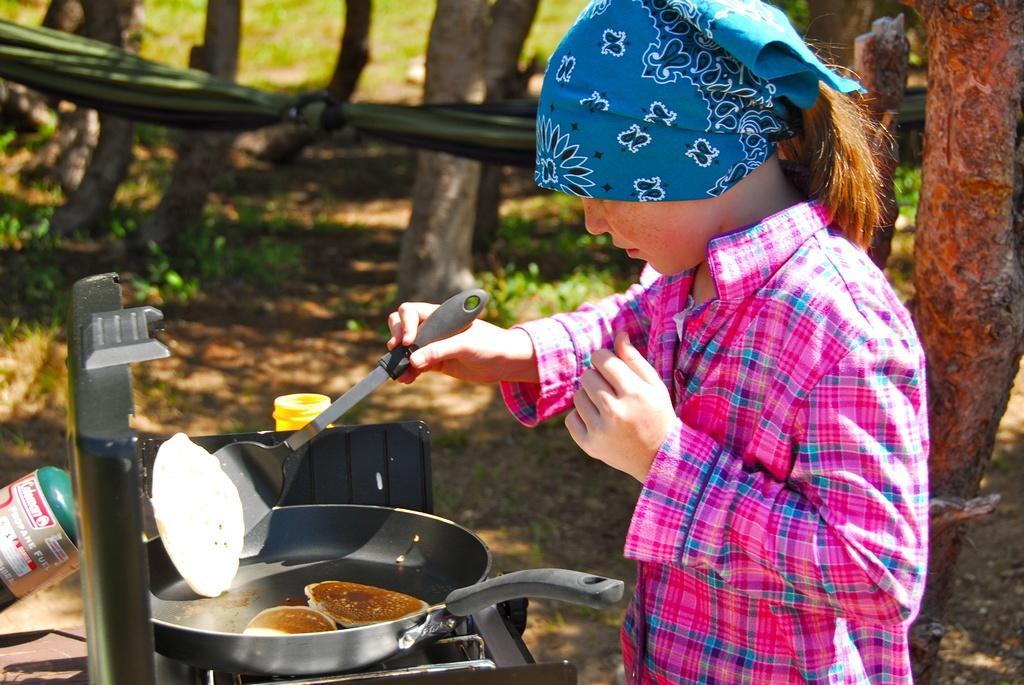In one or two sentences, can you explain what this image depicts? In this given image, I can see a women standing and holding a spoon and behind women, I can see a few trunk of a trees and i can see few objects. 